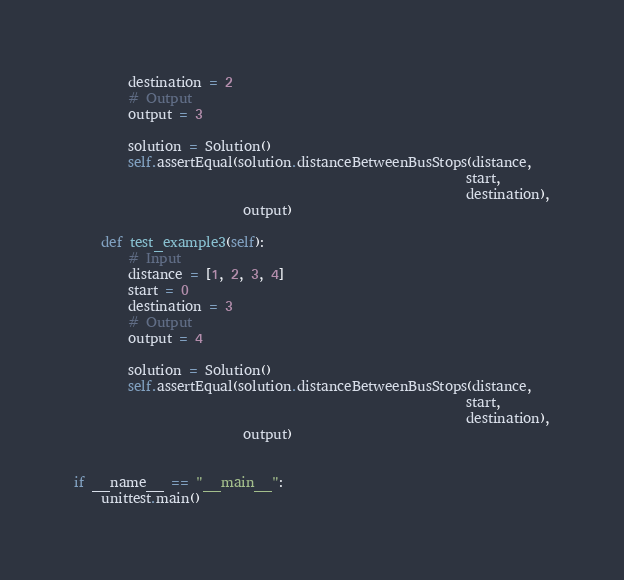<code> <loc_0><loc_0><loc_500><loc_500><_Python_>        destination = 2
        # Output
        output = 3

        solution = Solution()
        self.assertEqual(solution.distanceBetweenBusStops(distance,
                                                          start,
                                                          destination),
                         output)

    def test_example3(self):
        # Input
        distance = [1, 2, 3, 4]
        start = 0
        destination = 3
        # Output
        output = 4

        solution = Solution()
        self.assertEqual(solution.distanceBetweenBusStops(distance,
                                                          start,
                                                          destination),
                         output)


if __name__ == "__main__":
    unittest.main()
</code> 